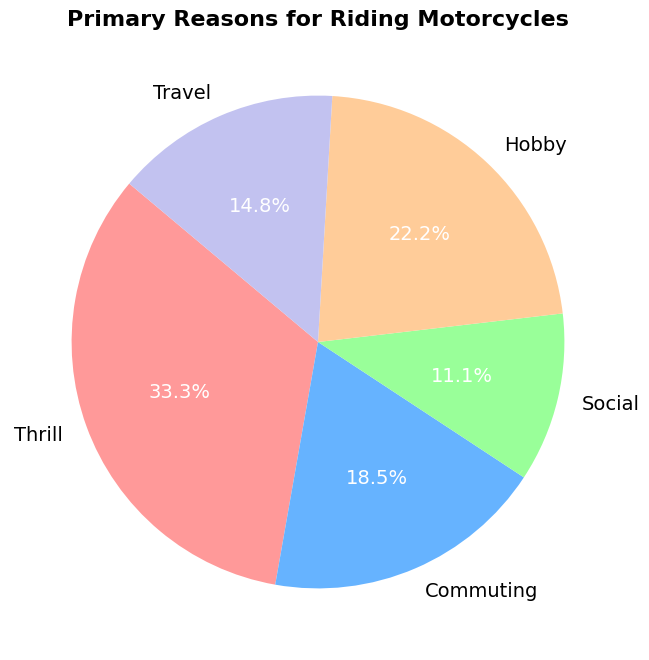Which reason has the largest proportion for riding motorcycles? The pie chart shows the different reasons with their respective proportions. The segment representing 'Thrill' is the largest slice in the chart.
Answer: Thrill Which reason has the smallest proportion for riding motorcycles? The pie chart shows the different reasons with their respective proportions. The segment representing 'Social' is the smallest slice in the chart.
Answer: Social How does the count of 'Hobby' compare to 'Commuting'? The data states that 'Hobby' has 30 counts and 'Commuting' has 25 counts. By comparing these numbers, 'Hobby' has 5 more counts than 'Commuting'.
Answer: Hobby has 5 more counts What is the sum of the percentages for 'Commuting' and 'Travel'? Refer to the pie chart for the percentages. 'Commuting' is 25 counts and 'Travel' is 20 counts, which is 25% and 20% respectively. Adding them together results in 45%.
Answer: 45% Identify the color representing 'Travel' in the pie chart. The pie chart uses different colors for each reason. The segment labeled 'Travel' is in a purple shade.
Answer: Purple What percentage of people ride for reasons other than Thrill? The 'Thrill' segment represents 45%. Therefore, reasons other than 'Thrill' account for 100% - 45% = 55% of the chart.
Answer: 55% Is the count of people riding for 'Social' reasons more than 'Travel'? The data shows 'Social' has 15 counts and 'Travel' has 20 counts. Therefore, 'Social' is less than 'Travel'.
Answer: No, Social is less than Travel If 'Thrill' and 'Hobby' are combined, what proportion of the total would that be? 'Thrill' has 45 counts and 'Hobby' has 30 counts. Together, they sum up to 75 counts. The total counts are 135, so the combined proportion is (75/135)*100 = 55.6%.
Answer: 55.6% What is the difference between the highest and lowest counts? The highest count is for 'Thrill' with 45 counts and the lowest is for 'Social' with 15 counts. The difference is 45 - 15 = 30 counts.
Answer: 30 counts Which two segments have the closest count and what is that difference? By visual inspection and verifying the counts, 'Commuting' (25 counts) and 'Travel' (20 counts) are the closest in count. The difference is 25 - 20 = 5 counts.
Answer: Commuting and Travel, 5 counts 